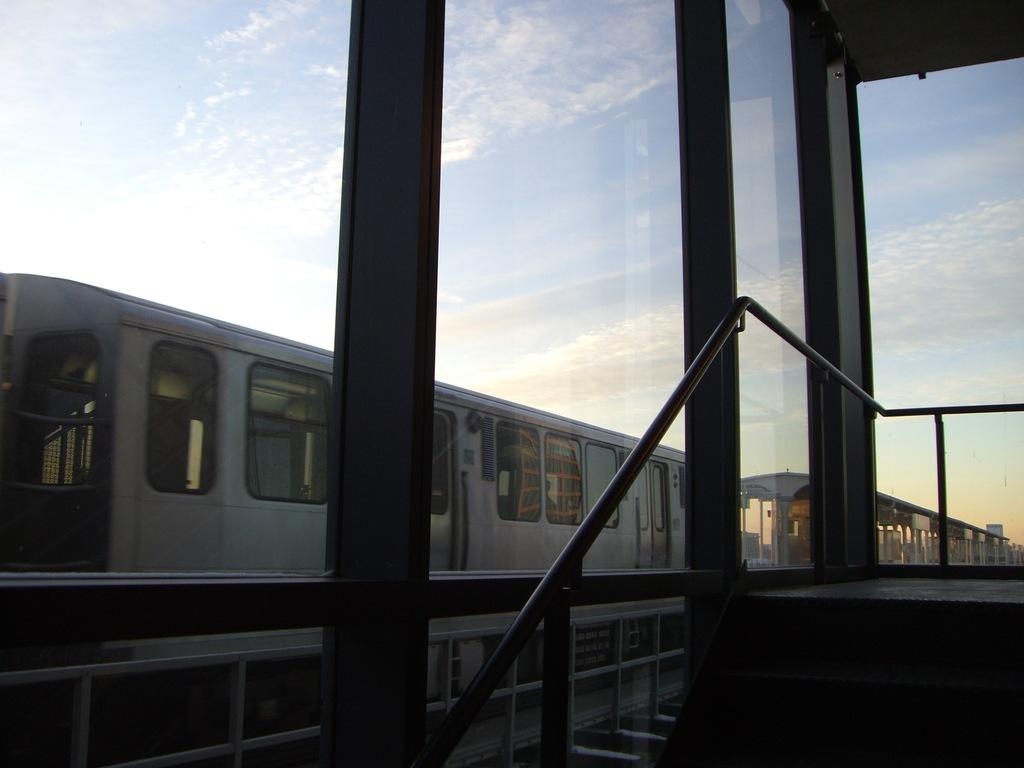What type of structure can be seen in the image? There is a railing in the image, which suggests a platform or balcony. What type of material is used for the windows in the image? The windows in the image are made of glass. What can be seen outside the glass windows? A train is visible on a railway track outside the glass windows. What is visible in the background of the image? Sky is visible in the background of the image. What can be observed in the sky? Clouds are present in the sky. Where is the waste disposal unit located in the image? There is no waste disposal unit present in the image. What type of form does the ant take in the image? There are no ants present in the image. 